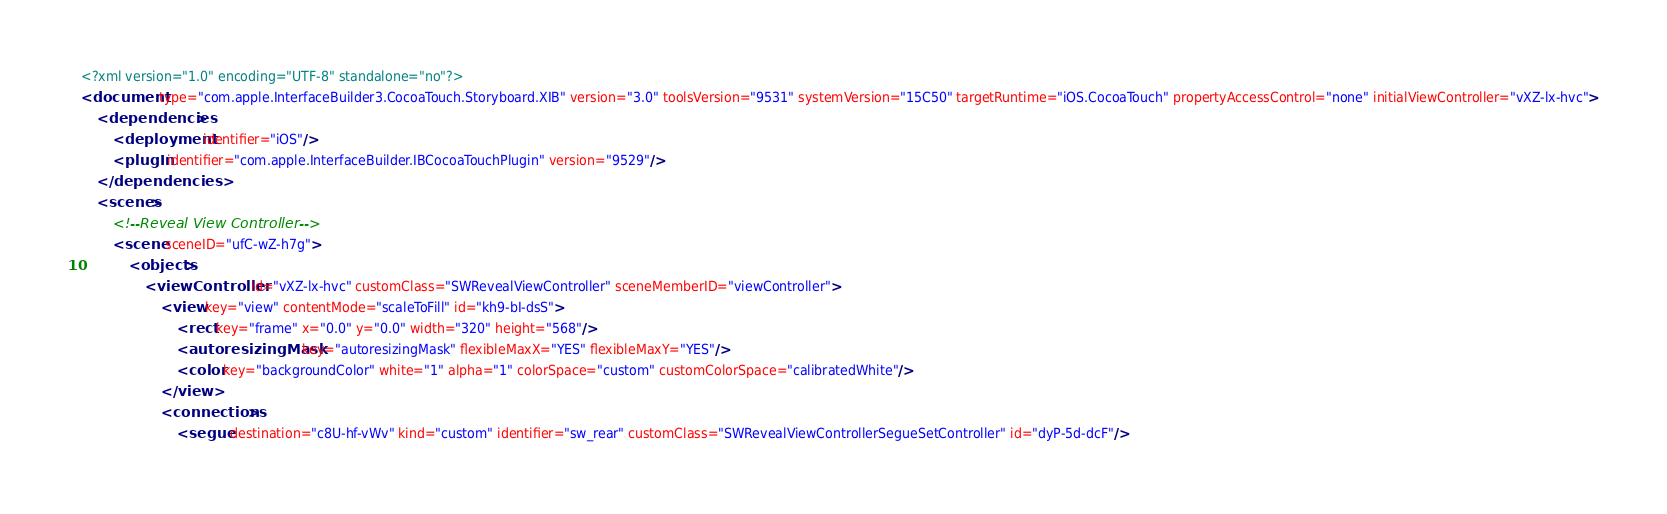Convert code to text. <code><loc_0><loc_0><loc_500><loc_500><_XML_><?xml version="1.0" encoding="UTF-8" standalone="no"?>
<document type="com.apple.InterfaceBuilder3.CocoaTouch.Storyboard.XIB" version="3.0" toolsVersion="9531" systemVersion="15C50" targetRuntime="iOS.CocoaTouch" propertyAccessControl="none" initialViewController="vXZ-lx-hvc">
    <dependencies>
        <deployment identifier="iOS"/>
        <plugIn identifier="com.apple.InterfaceBuilder.IBCocoaTouchPlugin" version="9529"/>
    </dependencies>
    <scenes>
        <!--Reveal View Controller-->
        <scene sceneID="ufC-wZ-h7g">
            <objects>
                <viewController id="vXZ-lx-hvc" customClass="SWRevealViewController" sceneMemberID="viewController">
                    <view key="view" contentMode="scaleToFill" id="kh9-bI-dsS">
                        <rect key="frame" x="0.0" y="0.0" width="320" height="568"/>
                        <autoresizingMask key="autoresizingMask" flexibleMaxX="YES" flexibleMaxY="YES"/>
                        <color key="backgroundColor" white="1" alpha="1" colorSpace="custom" customColorSpace="calibratedWhite"/>
                    </view>
                    <connections>
                        <segue destination="c8U-hf-vWv" kind="custom" identifier="sw_rear" customClass="SWRevealViewControllerSegueSetController" id="dyP-5d-dcF"/></code> 